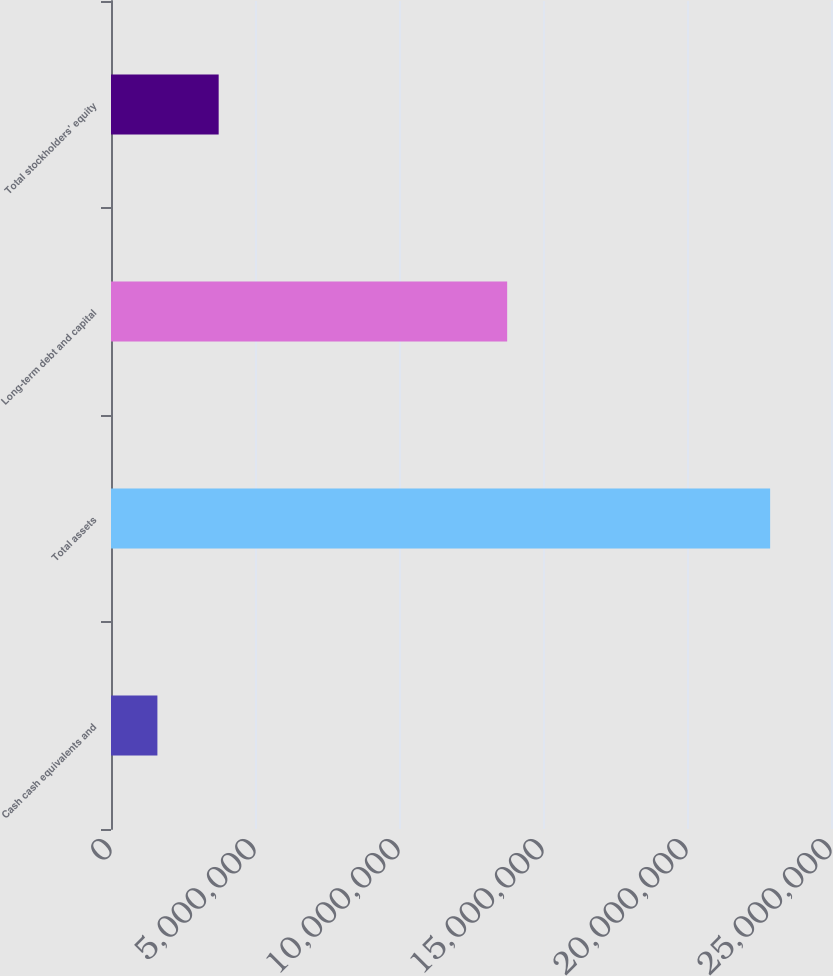<chart> <loc_0><loc_0><loc_500><loc_500><bar_chart><fcel>Cash cash equivalents and<fcel>Total assets<fcel>Long-term debt and capital<fcel>Total stockholders' equity<nl><fcel>1.61107e+06<fcel>2.28867e+07<fcel>1.37559e+07<fcel>3.73863e+06<nl></chart> 